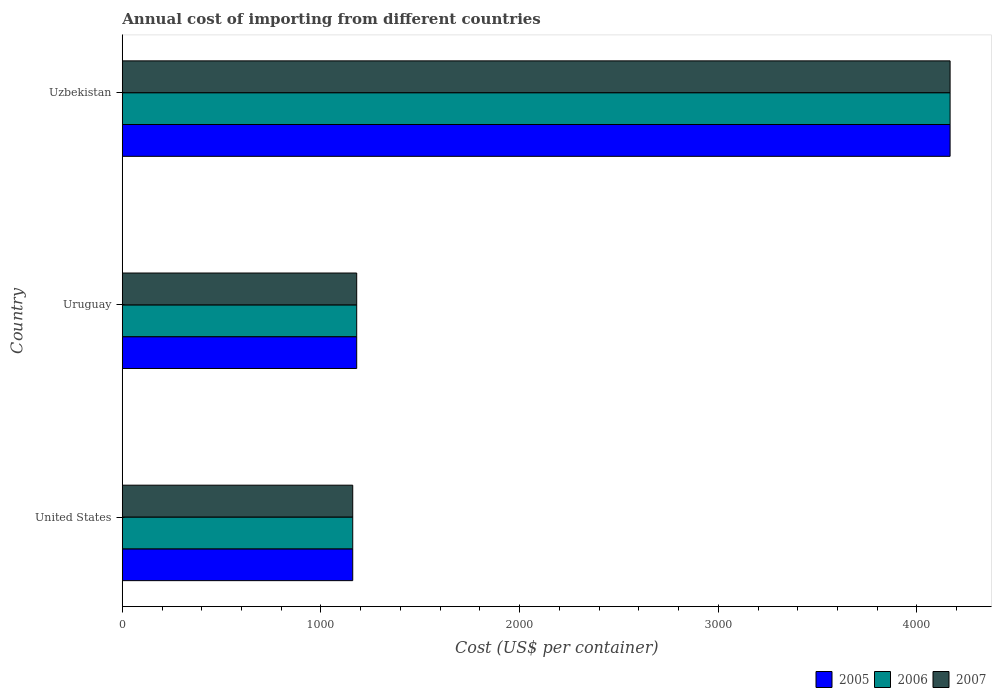How many different coloured bars are there?
Your answer should be compact. 3. How many groups of bars are there?
Your response must be concise. 3. How many bars are there on the 3rd tick from the bottom?
Give a very brief answer. 3. What is the label of the 2nd group of bars from the top?
Make the answer very short. Uruguay. What is the total annual cost of importing in 2005 in United States?
Give a very brief answer. 1160. Across all countries, what is the maximum total annual cost of importing in 2007?
Offer a very short reply. 4167. Across all countries, what is the minimum total annual cost of importing in 2005?
Offer a very short reply. 1160. In which country was the total annual cost of importing in 2006 maximum?
Keep it short and to the point. Uzbekistan. What is the total total annual cost of importing in 2006 in the graph?
Provide a succinct answer. 6507. What is the difference between the total annual cost of importing in 2007 in Uruguay and that in Uzbekistan?
Offer a terse response. -2987. What is the average total annual cost of importing in 2005 per country?
Give a very brief answer. 2169. What is the ratio of the total annual cost of importing in 2007 in United States to that in Uruguay?
Your answer should be compact. 0.98. Is the difference between the total annual cost of importing in 2007 in United States and Uzbekistan greater than the difference between the total annual cost of importing in 2005 in United States and Uzbekistan?
Your answer should be very brief. No. What is the difference between the highest and the second highest total annual cost of importing in 2006?
Ensure brevity in your answer.  2987. What is the difference between the highest and the lowest total annual cost of importing in 2007?
Offer a very short reply. 3007. What does the 3rd bar from the top in United States represents?
Your response must be concise. 2005. Is it the case that in every country, the sum of the total annual cost of importing in 2007 and total annual cost of importing in 2005 is greater than the total annual cost of importing in 2006?
Make the answer very short. Yes. How many countries are there in the graph?
Your answer should be compact. 3. What is the difference between two consecutive major ticks on the X-axis?
Provide a short and direct response. 1000. Are the values on the major ticks of X-axis written in scientific E-notation?
Make the answer very short. No. Does the graph contain any zero values?
Your response must be concise. No. How many legend labels are there?
Your answer should be compact. 3. How are the legend labels stacked?
Your answer should be compact. Horizontal. What is the title of the graph?
Provide a succinct answer. Annual cost of importing from different countries. Does "1986" appear as one of the legend labels in the graph?
Give a very brief answer. No. What is the label or title of the X-axis?
Provide a short and direct response. Cost (US$ per container). What is the label or title of the Y-axis?
Provide a succinct answer. Country. What is the Cost (US$ per container) of 2005 in United States?
Make the answer very short. 1160. What is the Cost (US$ per container) of 2006 in United States?
Offer a terse response. 1160. What is the Cost (US$ per container) of 2007 in United States?
Ensure brevity in your answer.  1160. What is the Cost (US$ per container) in 2005 in Uruguay?
Offer a very short reply. 1180. What is the Cost (US$ per container) of 2006 in Uruguay?
Offer a terse response. 1180. What is the Cost (US$ per container) of 2007 in Uruguay?
Provide a short and direct response. 1180. What is the Cost (US$ per container) in 2005 in Uzbekistan?
Keep it short and to the point. 4167. What is the Cost (US$ per container) of 2006 in Uzbekistan?
Provide a short and direct response. 4167. What is the Cost (US$ per container) of 2007 in Uzbekistan?
Your answer should be very brief. 4167. Across all countries, what is the maximum Cost (US$ per container) in 2005?
Offer a terse response. 4167. Across all countries, what is the maximum Cost (US$ per container) of 2006?
Keep it short and to the point. 4167. Across all countries, what is the maximum Cost (US$ per container) in 2007?
Offer a terse response. 4167. Across all countries, what is the minimum Cost (US$ per container) of 2005?
Your answer should be very brief. 1160. Across all countries, what is the minimum Cost (US$ per container) of 2006?
Ensure brevity in your answer.  1160. Across all countries, what is the minimum Cost (US$ per container) in 2007?
Ensure brevity in your answer.  1160. What is the total Cost (US$ per container) of 2005 in the graph?
Your response must be concise. 6507. What is the total Cost (US$ per container) in 2006 in the graph?
Make the answer very short. 6507. What is the total Cost (US$ per container) of 2007 in the graph?
Offer a terse response. 6507. What is the difference between the Cost (US$ per container) of 2005 in United States and that in Uruguay?
Offer a very short reply. -20. What is the difference between the Cost (US$ per container) of 2007 in United States and that in Uruguay?
Your answer should be compact. -20. What is the difference between the Cost (US$ per container) in 2005 in United States and that in Uzbekistan?
Offer a very short reply. -3007. What is the difference between the Cost (US$ per container) of 2006 in United States and that in Uzbekistan?
Ensure brevity in your answer.  -3007. What is the difference between the Cost (US$ per container) in 2007 in United States and that in Uzbekistan?
Make the answer very short. -3007. What is the difference between the Cost (US$ per container) in 2005 in Uruguay and that in Uzbekistan?
Provide a succinct answer. -2987. What is the difference between the Cost (US$ per container) in 2006 in Uruguay and that in Uzbekistan?
Your response must be concise. -2987. What is the difference between the Cost (US$ per container) in 2007 in Uruguay and that in Uzbekistan?
Your response must be concise. -2987. What is the difference between the Cost (US$ per container) in 2005 in United States and the Cost (US$ per container) in 2006 in Uruguay?
Ensure brevity in your answer.  -20. What is the difference between the Cost (US$ per container) in 2005 in United States and the Cost (US$ per container) in 2006 in Uzbekistan?
Your response must be concise. -3007. What is the difference between the Cost (US$ per container) of 2005 in United States and the Cost (US$ per container) of 2007 in Uzbekistan?
Offer a very short reply. -3007. What is the difference between the Cost (US$ per container) of 2006 in United States and the Cost (US$ per container) of 2007 in Uzbekistan?
Provide a succinct answer. -3007. What is the difference between the Cost (US$ per container) of 2005 in Uruguay and the Cost (US$ per container) of 2006 in Uzbekistan?
Keep it short and to the point. -2987. What is the difference between the Cost (US$ per container) of 2005 in Uruguay and the Cost (US$ per container) of 2007 in Uzbekistan?
Provide a succinct answer. -2987. What is the difference between the Cost (US$ per container) of 2006 in Uruguay and the Cost (US$ per container) of 2007 in Uzbekistan?
Your answer should be very brief. -2987. What is the average Cost (US$ per container) of 2005 per country?
Your response must be concise. 2169. What is the average Cost (US$ per container) in 2006 per country?
Offer a very short reply. 2169. What is the average Cost (US$ per container) of 2007 per country?
Offer a very short reply. 2169. What is the difference between the Cost (US$ per container) in 2006 and Cost (US$ per container) in 2007 in United States?
Your answer should be very brief. 0. What is the difference between the Cost (US$ per container) of 2005 and Cost (US$ per container) of 2006 in Uruguay?
Provide a short and direct response. 0. What is the difference between the Cost (US$ per container) of 2005 and Cost (US$ per container) of 2006 in Uzbekistan?
Give a very brief answer. 0. What is the ratio of the Cost (US$ per container) of 2005 in United States to that in Uruguay?
Make the answer very short. 0.98. What is the ratio of the Cost (US$ per container) in 2006 in United States to that in Uruguay?
Offer a very short reply. 0.98. What is the ratio of the Cost (US$ per container) in 2007 in United States to that in Uruguay?
Make the answer very short. 0.98. What is the ratio of the Cost (US$ per container) of 2005 in United States to that in Uzbekistan?
Provide a succinct answer. 0.28. What is the ratio of the Cost (US$ per container) in 2006 in United States to that in Uzbekistan?
Make the answer very short. 0.28. What is the ratio of the Cost (US$ per container) of 2007 in United States to that in Uzbekistan?
Your answer should be compact. 0.28. What is the ratio of the Cost (US$ per container) of 2005 in Uruguay to that in Uzbekistan?
Give a very brief answer. 0.28. What is the ratio of the Cost (US$ per container) in 2006 in Uruguay to that in Uzbekistan?
Offer a very short reply. 0.28. What is the ratio of the Cost (US$ per container) in 2007 in Uruguay to that in Uzbekistan?
Offer a terse response. 0.28. What is the difference between the highest and the second highest Cost (US$ per container) in 2005?
Make the answer very short. 2987. What is the difference between the highest and the second highest Cost (US$ per container) in 2006?
Your answer should be very brief. 2987. What is the difference between the highest and the second highest Cost (US$ per container) in 2007?
Provide a short and direct response. 2987. What is the difference between the highest and the lowest Cost (US$ per container) of 2005?
Ensure brevity in your answer.  3007. What is the difference between the highest and the lowest Cost (US$ per container) of 2006?
Your answer should be compact. 3007. What is the difference between the highest and the lowest Cost (US$ per container) of 2007?
Ensure brevity in your answer.  3007. 